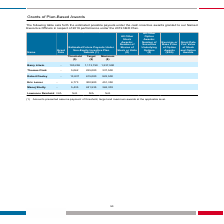From Systemax's financial document, What is the maximum estimated future payouts under the 2019 NEO plan for Barry Litwin and Thomas Clark? The document shows two values: 1,237,500 and 337,500. From the document: "Barry Litwin - 100,238 1,113,750 1,237,500 Thomas Clark - 5,062 225,000 337,500..." Also, What is the maximum estimated future payouts under the 2019 NEO plan for Robert Dooley and Eric Lerner? The document shows two values: 922,500 and 451,350. From the document: "Eric Lerner - 6,773 300,900 451,350 Robert Dooley - 13,837 615,000 922,500..." Also, What is the maximum estimated future payouts under the 2019 NEO plan for Manoj Shetty and Lawrence Reinhold? The document shows two values: 362,303 and N/A. From the document: "Lawrence Reinhold N/A N/A N/A N/A Manoj Shetty - 5,435 241,535 362,303..." Also, can you calculate: What is the difference between Manoj Shetty's estimated maximum and target payouts in the future under the 2019 NEO Plan? Based on the calculation: 362,303 - 241,535 , the result is 120768. This is based on the information: "Manoj Shetty - 5,435 241,535 362,303 Manoj Shetty - 5,435 241,535 362,303..." The key data points involved are: 241,535, 362,303. Also, can you calculate: What is Eric Lerner's threshold estimated future payouts under the 2019 NEO plan as a percentage of Thomas Clark's threshold payouts? Based on the calculation: 6,773/5,062 , the result is 133.8 (percentage). This is based on the information: "Eric Lerner - 6,773 300,900 451,350 Thomas Clark - 5,062 225,000 337,500..." The key data points involved are: 5,062, 6,773. Also, can you calculate: What is the total target payout under the 2019 NEO Plan for the highest and lowest paying Named Executive Officer under the 2019 NEO Plan? Based on the calculation: 1,113,750 + 225,000 , the result is 1338750. This is based on the information: "Barry Litwin - 100,238 1,113,750 1,237,500 Thomas Clark - 5,062 225,000 337,500..." The key data points involved are: 1,113,750, 225,000. 